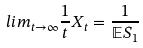Convert formula to latex. <formula><loc_0><loc_0><loc_500><loc_500>l i m _ { t \rightarrow \infty } \frac { 1 } { t } X _ { t } = \frac { 1 } { \mathbb { E } S _ { 1 } }</formula> 